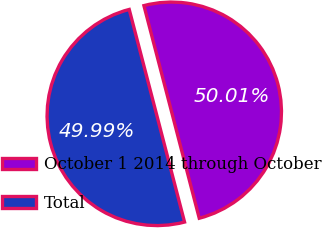<chart> <loc_0><loc_0><loc_500><loc_500><pie_chart><fcel>October 1 2014 through October<fcel>Total<nl><fcel>50.01%<fcel>49.99%<nl></chart> 